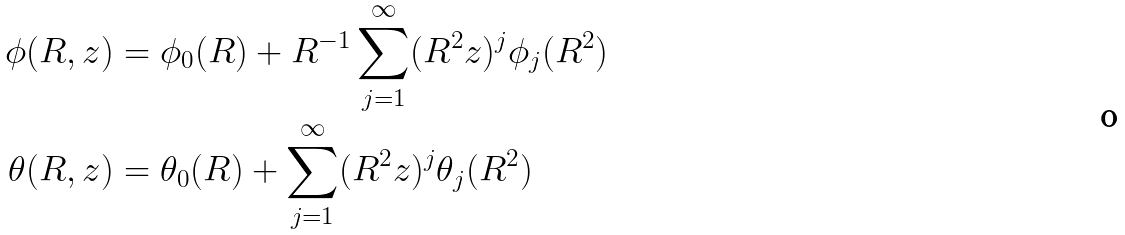<formula> <loc_0><loc_0><loc_500><loc_500>\phi ( R , z ) & = \phi _ { 0 } ( R ) + R ^ { - 1 } \sum _ { j = 1 } ^ { \infty } ( R ^ { 2 } z ) ^ { j } \phi _ { j } ( R ^ { 2 } ) \\ \theta ( R , z ) & = \theta _ { 0 } ( R ) + \sum _ { j = 1 } ^ { \infty } ( R ^ { 2 } z ) ^ { j } \theta _ { j } ( R ^ { 2 } )</formula> 